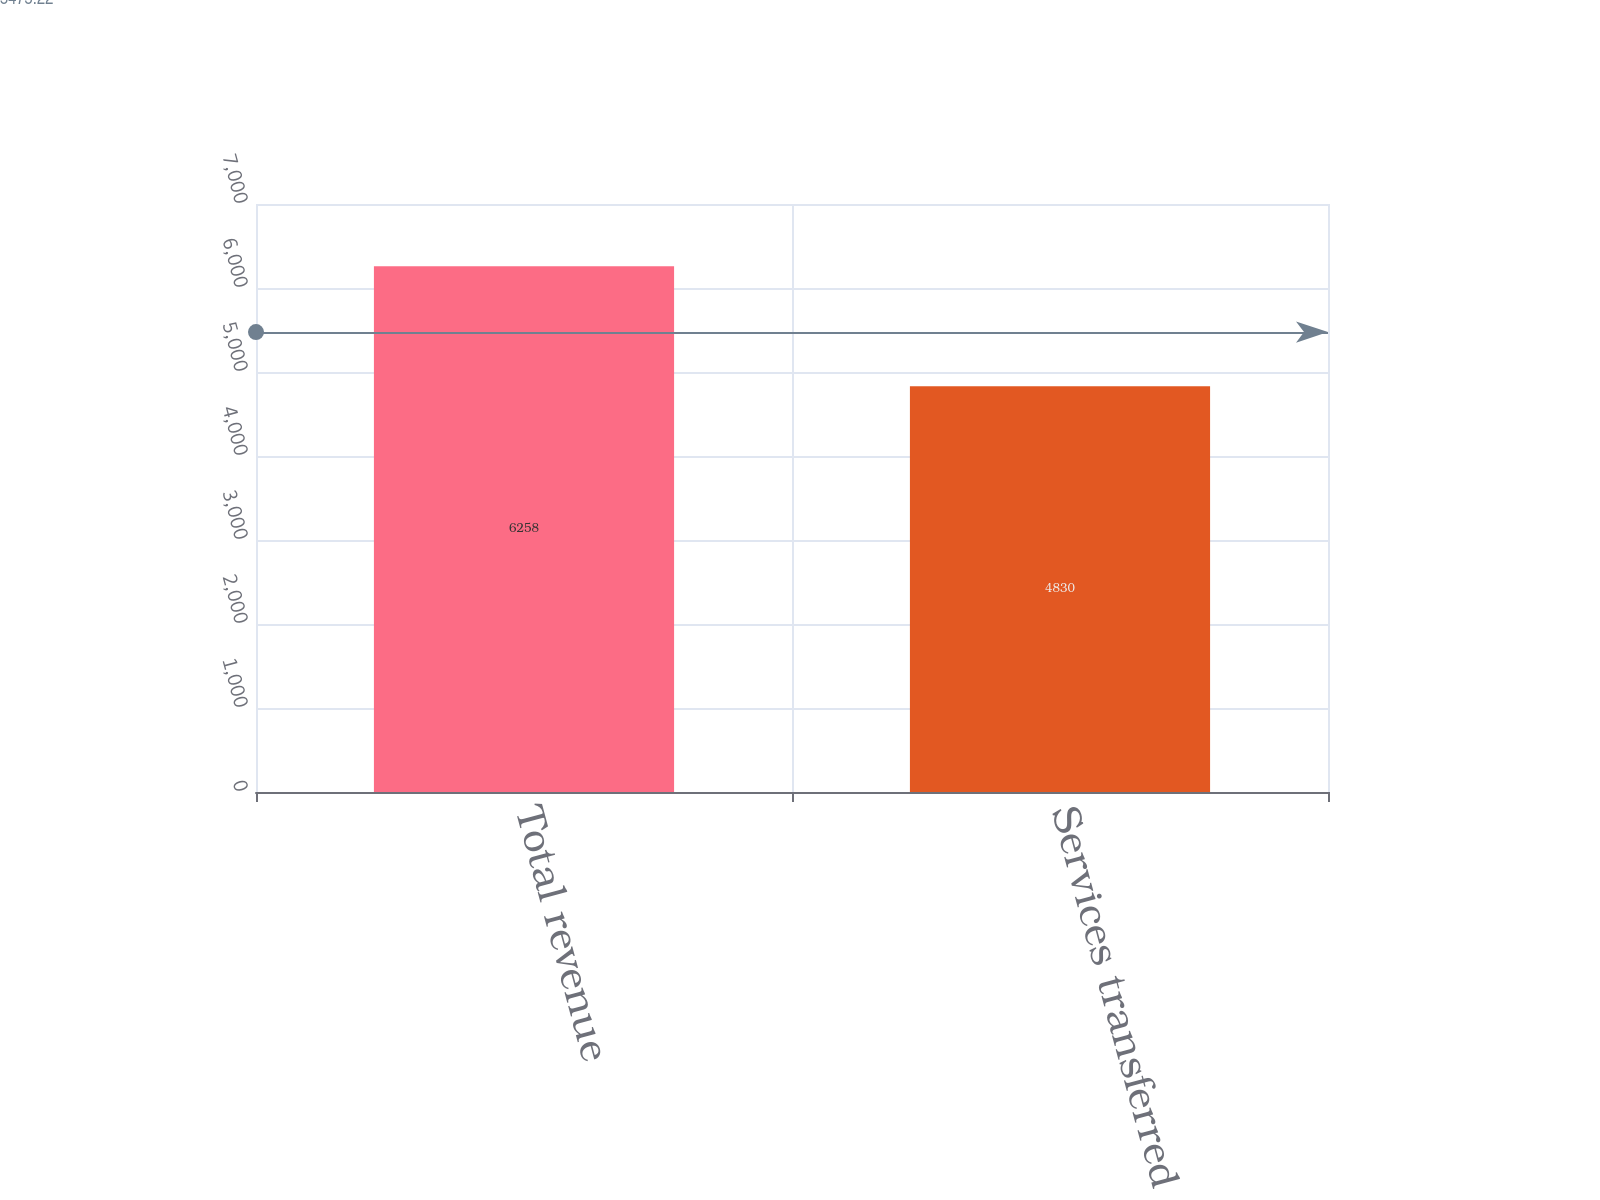Convert chart. <chart><loc_0><loc_0><loc_500><loc_500><bar_chart><fcel>Total revenue<fcel>Services transferred over time<nl><fcel>6258<fcel>4830<nl></chart> 